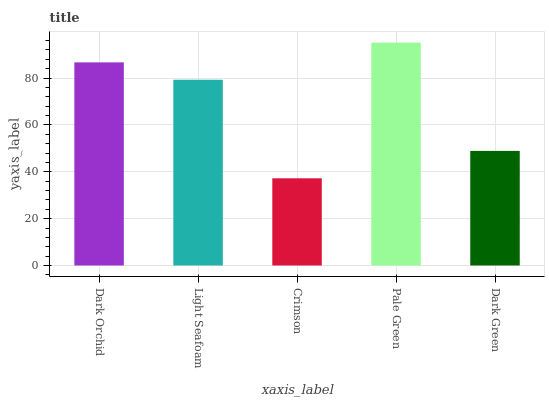Is Crimson the minimum?
Answer yes or no. Yes. Is Pale Green the maximum?
Answer yes or no. Yes. Is Light Seafoam the minimum?
Answer yes or no. No. Is Light Seafoam the maximum?
Answer yes or no. No. Is Dark Orchid greater than Light Seafoam?
Answer yes or no. Yes. Is Light Seafoam less than Dark Orchid?
Answer yes or no. Yes. Is Light Seafoam greater than Dark Orchid?
Answer yes or no. No. Is Dark Orchid less than Light Seafoam?
Answer yes or no. No. Is Light Seafoam the high median?
Answer yes or no. Yes. Is Light Seafoam the low median?
Answer yes or no. Yes. Is Dark Green the high median?
Answer yes or no. No. Is Crimson the low median?
Answer yes or no. No. 